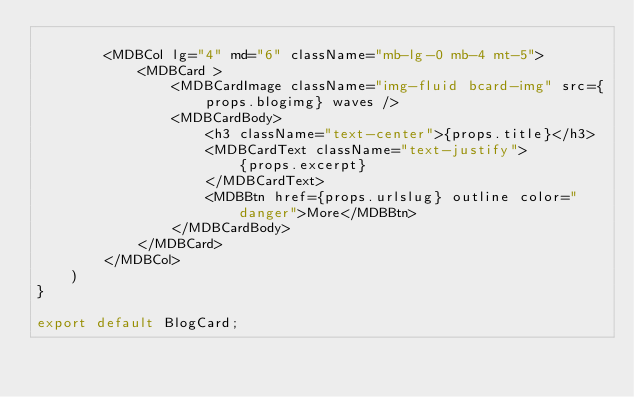<code> <loc_0><loc_0><loc_500><loc_500><_JavaScript_>
        <MDBCol lg="4" md="6" className="mb-lg-0 mb-4 mt-5">
            <MDBCard >
                <MDBCardImage className="img-fluid bcard-img" src={props.blogimg} waves />
                <MDBCardBody>
                    <h3 className="text-center">{props.title}</h3>
                    <MDBCardText className="text-justify">
                        {props.excerpt}
                    </MDBCardText>
                    <MDBBtn href={props.urlslug} outline color="danger">More</MDBBtn>
                </MDBCardBody>
            </MDBCard>
        </MDBCol>
    )
}

export default BlogCard;</code> 